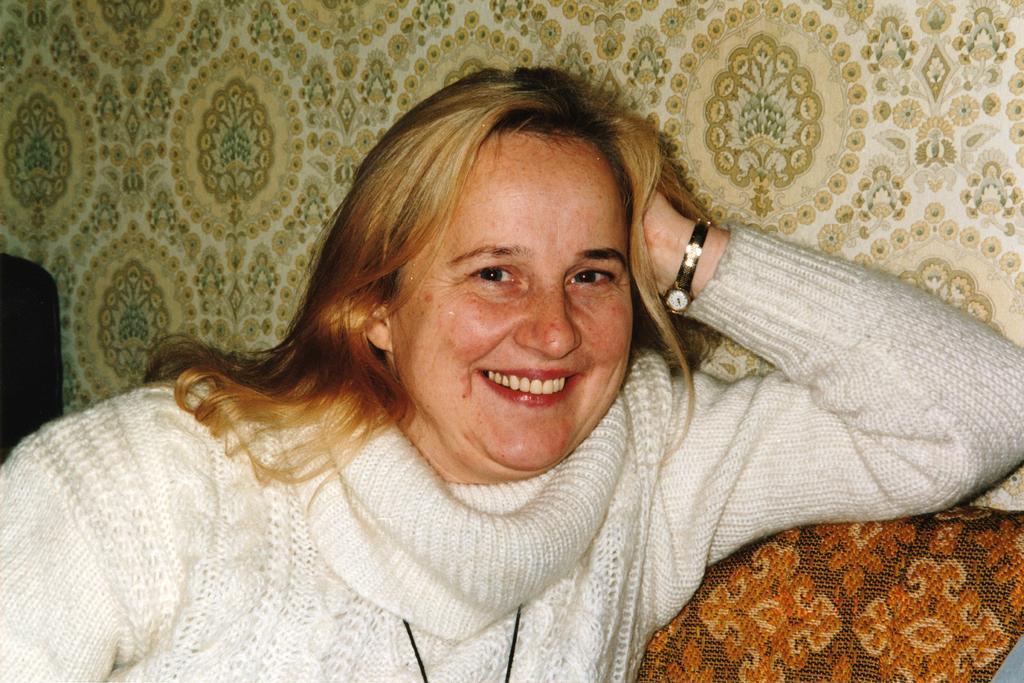In one or two sentences, can you explain what this image depicts? In this image we can see a woman sitting. On the backside we can see a wall. 